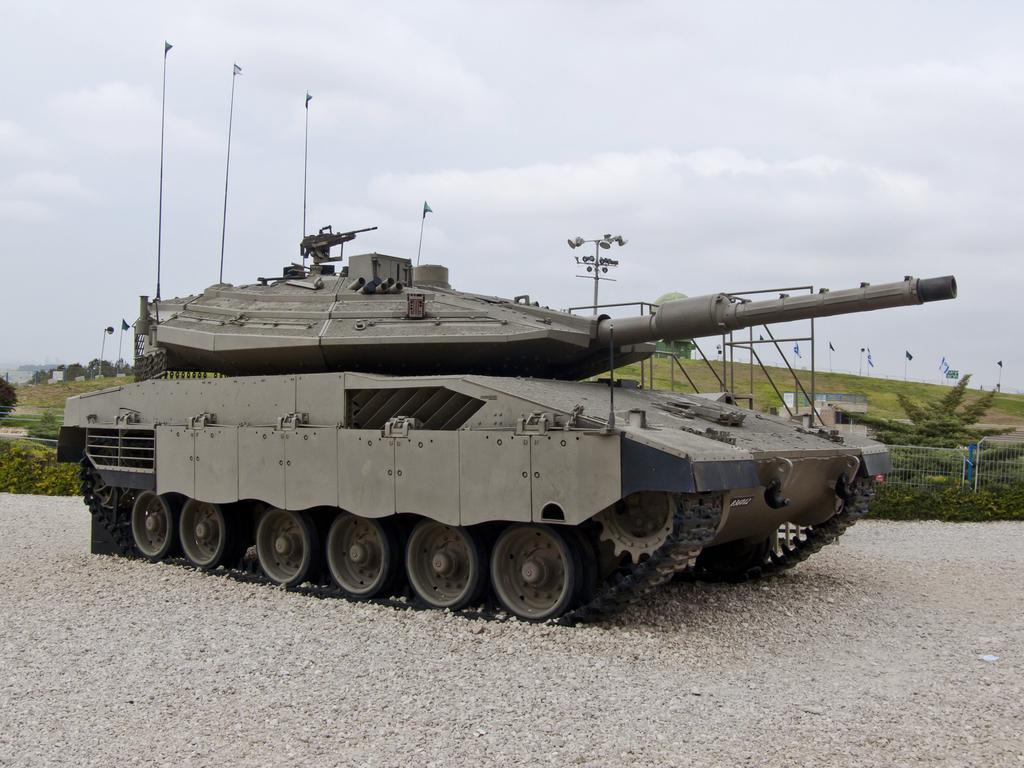Can you describe this image briefly? In this picture we can see a war tank on the ground, fence, trees, poles, flags, some objects and in the background we can see the sky. 